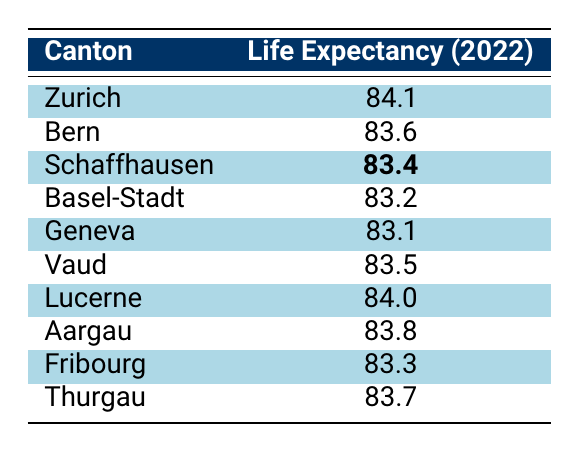What is the life expectancy in Zurich? From the table, the life expectancy for Zurich is directly listed as 84.1.
Answer: 84.1 Which canton has the lowest life expectancy? By looking at the life expectancy values, Geneva has the lowest at 83.1.
Answer: Geneva What is the average life expectancy of all cantons listed? To calculate the average, sum the life expectancies (84.1 + 83.6 + 83.4 + 83.2 + 83.1 + 83.5 + 84.0 + 83.8 + 83.3 + 83.7 = 834.7) and divide by the number of cantons (10), resulting in 834.7 / 10 = 83.47.
Answer: 83.47 Is the life expectancy in Schaffhausen greater than 83? The life expectancy for Schaffhausen is 83.4, which is indeed greater than 83.
Answer: Yes If we compare Zurich and Lucerne, which canton has a higher life expectancy and by how much? Zurich has a life expectancy of 84.1 and Lucerne has 84.0. The difference is calculated as 84.1 - 84.0 = 0.1, indicating Zurich has 0.1 higher life expectancy.
Answer: Zurich, 0.1 Which cantons are above the average life expectancy? The average life expectancy calculated was 83.47. The cantons above this average are Zurich (84.1), Lucerne (84.0), and Aargau (83.8). Therefore, three cantons exceed the average.
Answer: Zurich, Lucerne, Aargau Is the life expectancy in Basel-Stadt greater than that in Fribourg? Basel-Stadt has a life expectancy of 83.2 while Fribourg has 83.3. Since 83.2 is less than 83.3, the statement is false.
Answer: No What is the difference in life expectancy between the highest (Zurich) and the lowest (Geneva) canton? Zurich’s life expectancy is 84.1 and Geneva’s is 83.1. Calculating the difference gives us 84.1 - 83.1 = 1.0.
Answer: 1.0 How many cantons have a life expectancy between 83.4 and 84.0? The cantons in this range are Schaffhausen (83.4), Aargau (83.8), and Vaud (83.5). Thus, three cantons fall within this range.
Answer: 3 